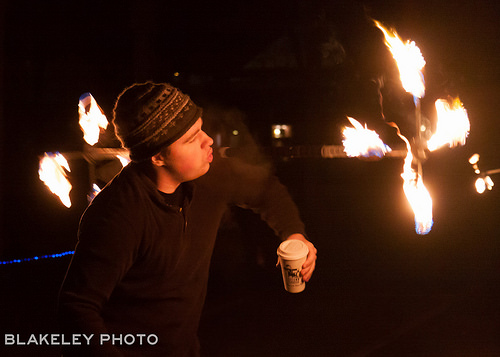<image>
Is the cup on the man? No. The cup is not positioned on the man. They may be near each other, but the cup is not supported by or resting on top of the man. 